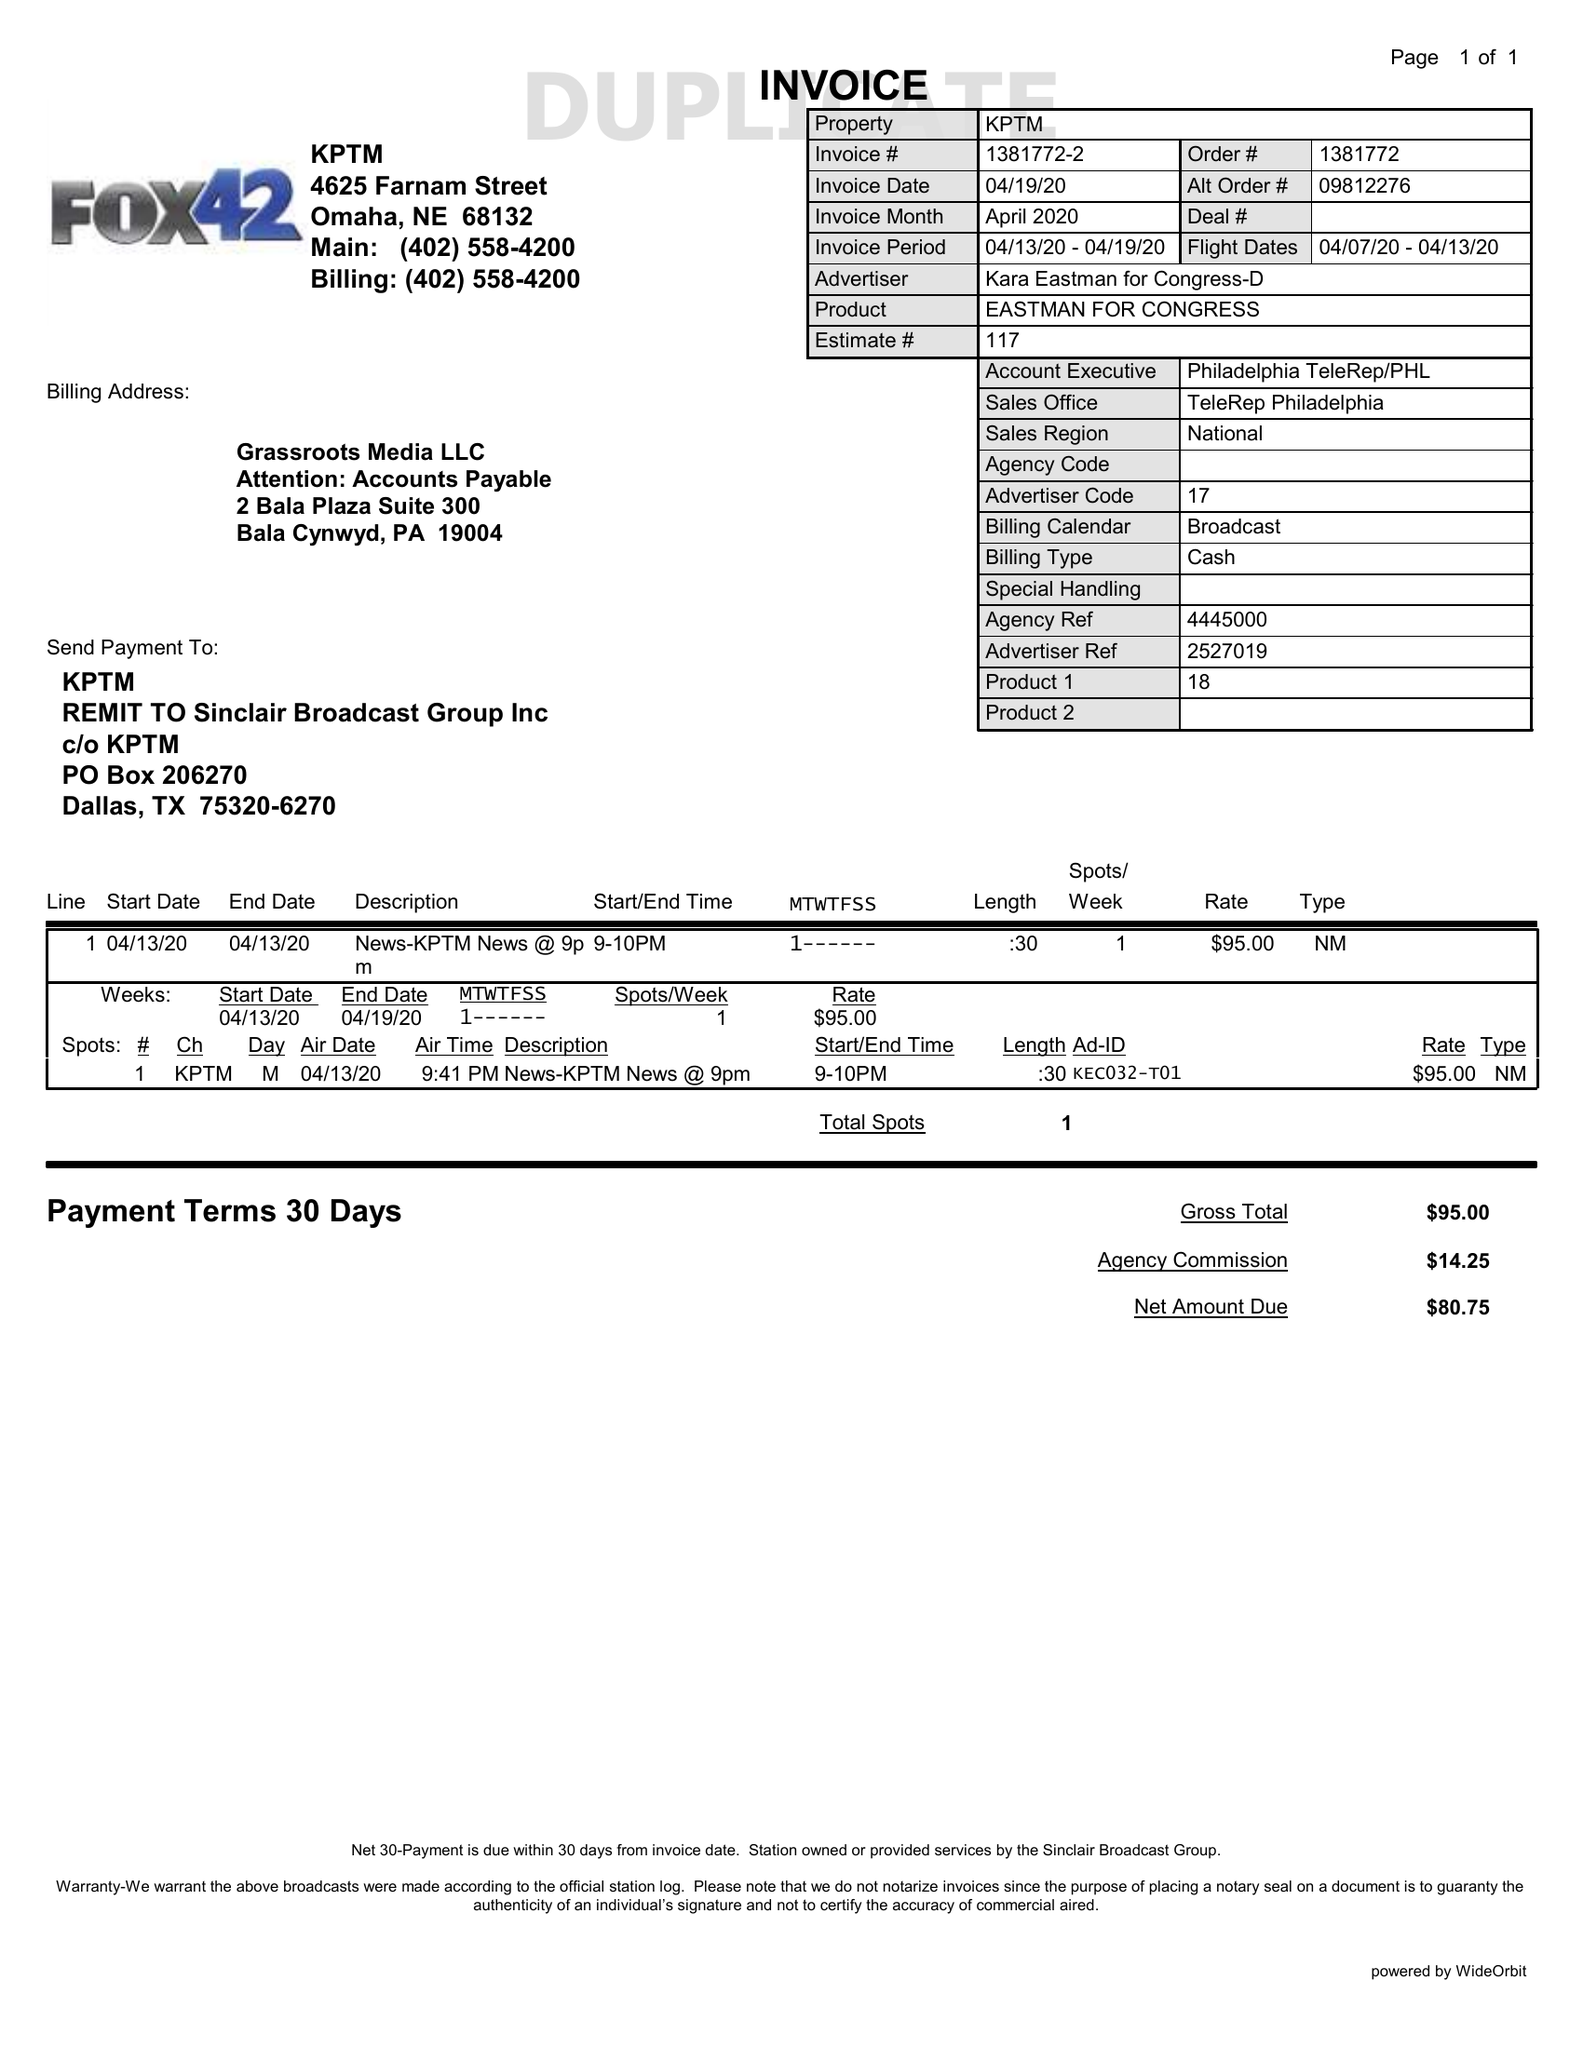What is the value for the flight_to?
Answer the question using a single word or phrase. 04/13/20 